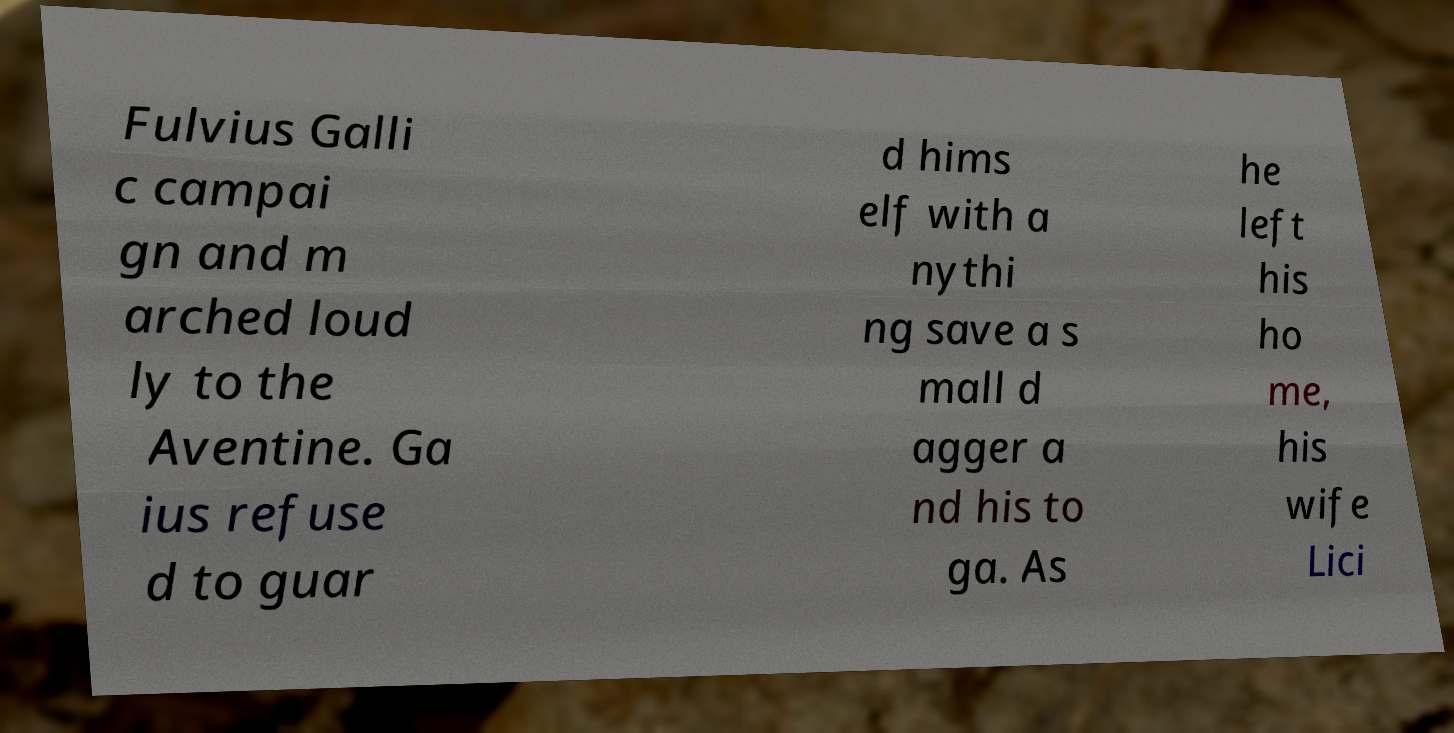Can you accurately transcribe the text from the provided image for me? Fulvius Galli c campai gn and m arched loud ly to the Aventine. Ga ius refuse d to guar d hims elf with a nythi ng save a s mall d agger a nd his to ga. As he left his ho me, his wife Lici 